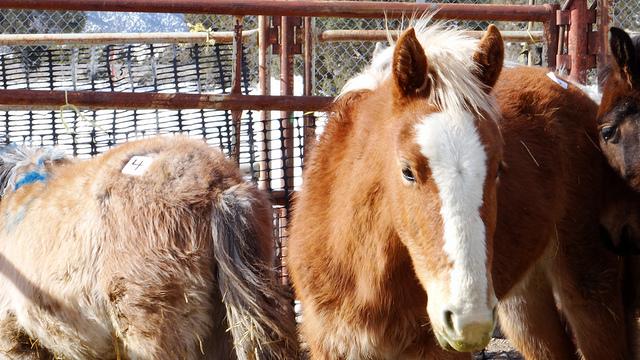How many horses are shown?
Keep it brief. 3. Where is the horse?
Keep it brief. In pen. What color is the horse on the right?
Answer briefly. Brown. 